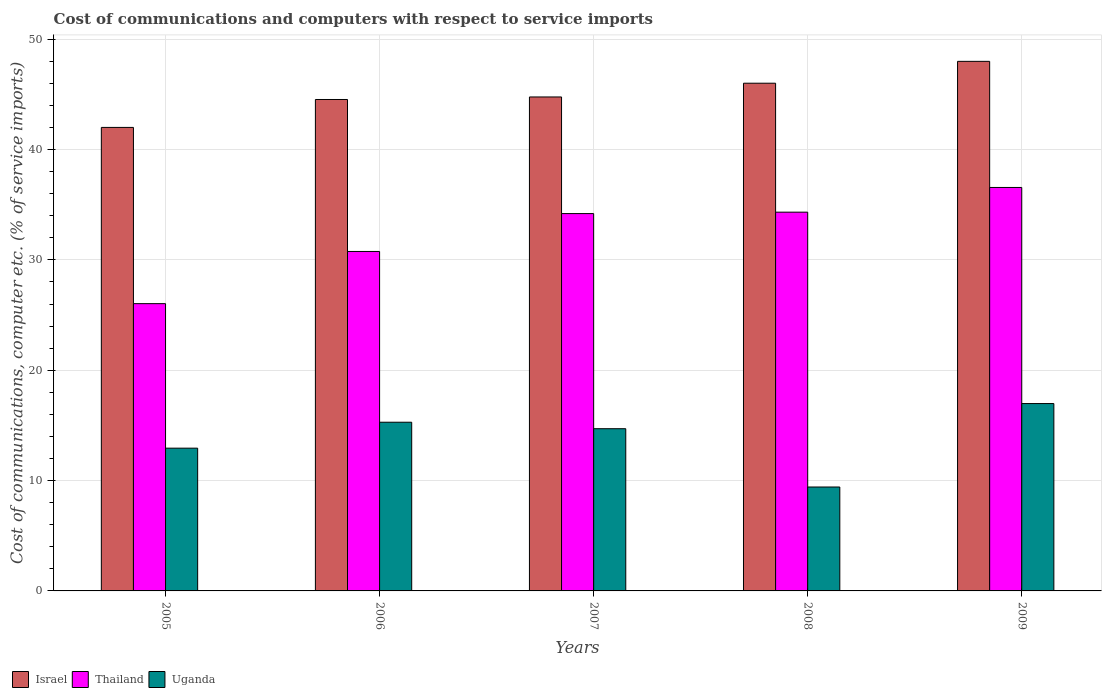How many groups of bars are there?
Your answer should be very brief. 5. Are the number of bars on each tick of the X-axis equal?
Provide a succinct answer. Yes. How many bars are there on the 3rd tick from the left?
Your answer should be very brief. 3. How many bars are there on the 2nd tick from the right?
Your answer should be compact. 3. What is the label of the 5th group of bars from the left?
Your response must be concise. 2009. In how many cases, is the number of bars for a given year not equal to the number of legend labels?
Offer a terse response. 0. What is the cost of communications and computers in Thailand in 2006?
Offer a very short reply. 30.77. Across all years, what is the maximum cost of communications and computers in Thailand?
Your answer should be very brief. 36.57. Across all years, what is the minimum cost of communications and computers in Uganda?
Provide a short and direct response. 9.42. In which year was the cost of communications and computers in Israel maximum?
Give a very brief answer. 2009. What is the total cost of communications and computers in Thailand in the graph?
Provide a succinct answer. 161.89. What is the difference between the cost of communications and computers in Thailand in 2007 and that in 2009?
Ensure brevity in your answer.  -2.37. What is the difference between the cost of communications and computers in Uganda in 2009 and the cost of communications and computers in Thailand in 2006?
Provide a short and direct response. -13.78. What is the average cost of communications and computers in Israel per year?
Make the answer very short. 45.06. In the year 2005, what is the difference between the cost of communications and computers in Thailand and cost of communications and computers in Uganda?
Offer a terse response. 13.1. In how many years, is the cost of communications and computers in Uganda greater than 22 %?
Your answer should be very brief. 0. What is the ratio of the cost of communications and computers in Israel in 2005 to that in 2009?
Offer a terse response. 0.88. What is the difference between the highest and the second highest cost of communications and computers in Israel?
Keep it short and to the point. 1.98. What is the difference between the highest and the lowest cost of communications and computers in Thailand?
Make the answer very short. 10.53. In how many years, is the cost of communications and computers in Thailand greater than the average cost of communications and computers in Thailand taken over all years?
Make the answer very short. 3. Is the sum of the cost of communications and computers in Israel in 2005 and 2009 greater than the maximum cost of communications and computers in Uganda across all years?
Keep it short and to the point. Yes. What does the 3rd bar from the left in 2007 represents?
Your answer should be compact. Uganda. What does the 3rd bar from the right in 2006 represents?
Provide a short and direct response. Israel. Is it the case that in every year, the sum of the cost of communications and computers in Israel and cost of communications and computers in Thailand is greater than the cost of communications and computers in Uganda?
Your response must be concise. Yes. How many bars are there?
Offer a very short reply. 15. What is the difference between two consecutive major ticks on the Y-axis?
Your response must be concise. 10. Are the values on the major ticks of Y-axis written in scientific E-notation?
Keep it short and to the point. No. Does the graph contain any zero values?
Keep it short and to the point. No. Does the graph contain grids?
Offer a very short reply. Yes. How many legend labels are there?
Offer a terse response. 3. What is the title of the graph?
Keep it short and to the point. Cost of communications and computers with respect to service imports. Does "Ghana" appear as one of the legend labels in the graph?
Keep it short and to the point. No. What is the label or title of the Y-axis?
Ensure brevity in your answer.  Cost of communications, computer etc. (% of service imports). What is the Cost of communications, computer etc. (% of service imports) of Israel in 2005?
Provide a succinct answer. 42.01. What is the Cost of communications, computer etc. (% of service imports) of Thailand in 2005?
Your answer should be very brief. 26.04. What is the Cost of communications, computer etc. (% of service imports) of Uganda in 2005?
Make the answer very short. 12.94. What is the Cost of communications, computer etc. (% of service imports) in Israel in 2006?
Your response must be concise. 44.54. What is the Cost of communications, computer etc. (% of service imports) of Thailand in 2006?
Ensure brevity in your answer.  30.77. What is the Cost of communications, computer etc. (% of service imports) of Uganda in 2006?
Provide a succinct answer. 15.29. What is the Cost of communications, computer etc. (% of service imports) in Israel in 2007?
Offer a terse response. 44.77. What is the Cost of communications, computer etc. (% of service imports) of Thailand in 2007?
Your answer should be compact. 34.2. What is the Cost of communications, computer etc. (% of service imports) of Uganda in 2007?
Your answer should be very brief. 14.7. What is the Cost of communications, computer etc. (% of service imports) of Israel in 2008?
Offer a terse response. 46.01. What is the Cost of communications, computer etc. (% of service imports) in Thailand in 2008?
Your response must be concise. 34.33. What is the Cost of communications, computer etc. (% of service imports) of Uganda in 2008?
Keep it short and to the point. 9.42. What is the Cost of communications, computer etc. (% of service imports) in Israel in 2009?
Provide a succinct answer. 48. What is the Cost of communications, computer etc. (% of service imports) in Thailand in 2009?
Make the answer very short. 36.57. What is the Cost of communications, computer etc. (% of service imports) of Uganda in 2009?
Your response must be concise. 16.98. Across all years, what is the maximum Cost of communications, computer etc. (% of service imports) in Israel?
Ensure brevity in your answer.  48. Across all years, what is the maximum Cost of communications, computer etc. (% of service imports) in Thailand?
Provide a succinct answer. 36.57. Across all years, what is the maximum Cost of communications, computer etc. (% of service imports) in Uganda?
Your answer should be very brief. 16.98. Across all years, what is the minimum Cost of communications, computer etc. (% of service imports) in Israel?
Make the answer very short. 42.01. Across all years, what is the minimum Cost of communications, computer etc. (% of service imports) in Thailand?
Your answer should be very brief. 26.04. Across all years, what is the minimum Cost of communications, computer etc. (% of service imports) of Uganda?
Offer a very short reply. 9.42. What is the total Cost of communications, computer etc. (% of service imports) in Israel in the graph?
Your answer should be very brief. 225.32. What is the total Cost of communications, computer etc. (% of service imports) in Thailand in the graph?
Make the answer very short. 161.89. What is the total Cost of communications, computer etc. (% of service imports) of Uganda in the graph?
Offer a terse response. 69.33. What is the difference between the Cost of communications, computer etc. (% of service imports) in Israel in 2005 and that in 2006?
Keep it short and to the point. -2.53. What is the difference between the Cost of communications, computer etc. (% of service imports) of Thailand in 2005 and that in 2006?
Your response must be concise. -4.73. What is the difference between the Cost of communications, computer etc. (% of service imports) of Uganda in 2005 and that in 2006?
Ensure brevity in your answer.  -2.35. What is the difference between the Cost of communications, computer etc. (% of service imports) of Israel in 2005 and that in 2007?
Provide a short and direct response. -2.76. What is the difference between the Cost of communications, computer etc. (% of service imports) in Thailand in 2005 and that in 2007?
Keep it short and to the point. -8.16. What is the difference between the Cost of communications, computer etc. (% of service imports) in Uganda in 2005 and that in 2007?
Make the answer very short. -1.76. What is the difference between the Cost of communications, computer etc. (% of service imports) in Israel in 2005 and that in 2008?
Offer a terse response. -4.01. What is the difference between the Cost of communications, computer etc. (% of service imports) of Thailand in 2005 and that in 2008?
Your answer should be very brief. -8.29. What is the difference between the Cost of communications, computer etc. (% of service imports) of Uganda in 2005 and that in 2008?
Provide a short and direct response. 3.52. What is the difference between the Cost of communications, computer etc. (% of service imports) in Israel in 2005 and that in 2009?
Ensure brevity in your answer.  -5.99. What is the difference between the Cost of communications, computer etc. (% of service imports) of Thailand in 2005 and that in 2009?
Offer a very short reply. -10.53. What is the difference between the Cost of communications, computer etc. (% of service imports) of Uganda in 2005 and that in 2009?
Provide a succinct answer. -4.04. What is the difference between the Cost of communications, computer etc. (% of service imports) of Israel in 2006 and that in 2007?
Make the answer very short. -0.23. What is the difference between the Cost of communications, computer etc. (% of service imports) of Thailand in 2006 and that in 2007?
Your answer should be very brief. -3.43. What is the difference between the Cost of communications, computer etc. (% of service imports) in Uganda in 2006 and that in 2007?
Your answer should be very brief. 0.59. What is the difference between the Cost of communications, computer etc. (% of service imports) of Israel in 2006 and that in 2008?
Provide a short and direct response. -1.48. What is the difference between the Cost of communications, computer etc. (% of service imports) in Thailand in 2006 and that in 2008?
Provide a succinct answer. -3.56. What is the difference between the Cost of communications, computer etc. (% of service imports) of Uganda in 2006 and that in 2008?
Ensure brevity in your answer.  5.87. What is the difference between the Cost of communications, computer etc. (% of service imports) of Israel in 2006 and that in 2009?
Your answer should be compact. -3.46. What is the difference between the Cost of communications, computer etc. (% of service imports) in Thailand in 2006 and that in 2009?
Offer a terse response. -5.8. What is the difference between the Cost of communications, computer etc. (% of service imports) in Uganda in 2006 and that in 2009?
Your answer should be very brief. -1.69. What is the difference between the Cost of communications, computer etc. (% of service imports) in Israel in 2007 and that in 2008?
Your response must be concise. -1.25. What is the difference between the Cost of communications, computer etc. (% of service imports) of Thailand in 2007 and that in 2008?
Provide a short and direct response. -0.13. What is the difference between the Cost of communications, computer etc. (% of service imports) of Uganda in 2007 and that in 2008?
Provide a short and direct response. 5.28. What is the difference between the Cost of communications, computer etc. (% of service imports) in Israel in 2007 and that in 2009?
Make the answer very short. -3.23. What is the difference between the Cost of communications, computer etc. (% of service imports) in Thailand in 2007 and that in 2009?
Give a very brief answer. -2.37. What is the difference between the Cost of communications, computer etc. (% of service imports) of Uganda in 2007 and that in 2009?
Keep it short and to the point. -2.28. What is the difference between the Cost of communications, computer etc. (% of service imports) in Israel in 2008 and that in 2009?
Your answer should be compact. -1.98. What is the difference between the Cost of communications, computer etc. (% of service imports) in Thailand in 2008 and that in 2009?
Offer a very short reply. -2.24. What is the difference between the Cost of communications, computer etc. (% of service imports) in Uganda in 2008 and that in 2009?
Ensure brevity in your answer.  -7.56. What is the difference between the Cost of communications, computer etc. (% of service imports) of Israel in 2005 and the Cost of communications, computer etc. (% of service imports) of Thailand in 2006?
Offer a terse response. 11.24. What is the difference between the Cost of communications, computer etc. (% of service imports) of Israel in 2005 and the Cost of communications, computer etc. (% of service imports) of Uganda in 2006?
Your answer should be very brief. 26.72. What is the difference between the Cost of communications, computer etc. (% of service imports) of Thailand in 2005 and the Cost of communications, computer etc. (% of service imports) of Uganda in 2006?
Offer a terse response. 10.75. What is the difference between the Cost of communications, computer etc. (% of service imports) of Israel in 2005 and the Cost of communications, computer etc. (% of service imports) of Thailand in 2007?
Your answer should be very brief. 7.81. What is the difference between the Cost of communications, computer etc. (% of service imports) of Israel in 2005 and the Cost of communications, computer etc. (% of service imports) of Uganda in 2007?
Give a very brief answer. 27.31. What is the difference between the Cost of communications, computer etc. (% of service imports) of Thailand in 2005 and the Cost of communications, computer etc. (% of service imports) of Uganda in 2007?
Your answer should be compact. 11.33. What is the difference between the Cost of communications, computer etc. (% of service imports) in Israel in 2005 and the Cost of communications, computer etc. (% of service imports) in Thailand in 2008?
Provide a short and direct response. 7.68. What is the difference between the Cost of communications, computer etc. (% of service imports) in Israel in 2005 and the Cost of communications, computer etc. (% of service imports) in Uganda in 2008?
Ensure brevity in your answer.  32.59. What is the difference between the Cost of communications, computer etc. (% of service imports) in Thailand in 2005 and the Cost of communications, computer etc. (% of service imports) in Uganda in 2008?
Ensure brevity in your answer.  16.62. What is the difference between the Cost of communications, computer etc. (% of service imports) of Israel in 2005 and the Cost of communications, computer etc. (% of service imports) of Thailand in 2009?
Provide a short and direct response. 5.44. What is the difference between the Cost of communications, computer etc. (% of service imports) in Israel in 2005 and the Cost of communications, computer etc. (% of service imports) in Uganda in 2009?
Give a very brief answer. 25.03. What is the difference between the Cost of communications, computer etc. (% of service imports) in Thailand in 2005 and the Cost of communications, computer etc. (% of service imports) in Uganda in 2009?
Your answer should be compact. 9.06. What is the difference between the Cost of communications, computer etc. (% of service imports) in Israel in 2006 and the Cost of communications, computer etc. (% of service imports) in Thailand in 2007?
Your response must be concise. 10.34. What is the difference between the Cost of communications, computer etc. (% of service imports) in Israel in 2006 and the Cost of communications, computer etc. (% of service imports) in Uganda in 2007?
Your answer should be compact. 29.84. What is the difference between the Cost of communications, computer etc. (% of service imports) in Thailand in 2006 and the Cost of communications, computer etc. (% of service imports) in Uganda in 2007?
Provide a short and direct response. 16.06. What is the difference between the Cost of communications, computer etc. (% of service imports) in Israel in 2006 and the Cost of communications, computer etc. (% of service imports) in Thailand in 2008?
Your response must be concise. 10.21. What is the difference between the Cost of communications, computer etc. (% of service imports) in Israel in 2006 and the Cost of communications, computer etc. (% of service imports) in Uganda in 2008?
Offer a very short reply. 35.12. What is the difference between the Cost of communications, computer etc. (% of service imports) of Thailand in 2006 and the Cost of communications, computer etc. (% of service imports) of Uganda in 2008?
Your answer should be very brief. 21.35. What is the difference between the Cost of communications, computer etc. (% of service imports) in Israel in 2006 and the Cost of communications, computer etc. (% of service imports) in Thailand in 2009?
Keep it short and to the point. 7.97. What is the difference between the Cost of communications, computer etc. (% of service imports) of Israel in 2006 and the Cost of communications, computer etc. (% of service imports) of Uganda in 2009?
Provide a succinct answer. 27.56. What is the difference between the Cost of communications, computer etc. (% of service imports) in Thailand in 2006 and the Cost of communications, computer etc. (% of service imports) in Uganda in 2009?
Provide a short and direct response. 13.78. What is the difference between the Cost of communications, computer etc. (% of service imports) in Israel in 2007 and the Cost of communications, computer etc. (% of service imports) in Thailand in 2008?
Your answer should be very brief. 10.44. What is the difference between the Cost of communications, computer etc. (% of service imports) of Israel in 2007 and the Cost of communications, computer etc. (% of service imports) of Uganda in 2008?
Provide a short and direct response. 35.35. What is the difference between the Cost of communications, computer etc. (% of service imports) in Thailand in 2007 and the Cost of communications, computer etc. (% of service imports) in Uganda in 2008?
Provide a short and direct response. 24.78. What is the difference between the Cost of communications, computer etc. (% of service imports) in Israel in 2007 and the Cost of communications, computer etc. (% of service imports) in Thailand in 2009?
Ensure brevity in your answer.  8.2. What is the difference between the Cost of communications, computer etc. (% of service imports) in Israel in 2007 and the Cost of communications, computer etc. (% of service imports) in Uganda in 2009?
Keep it short and to the point. 27.79. What is the difference between the Cost of communications, computer etc. (% of service imports) in Thailand in 2007 and the Cost of communications, computer etc. (% of service imports) in Uganda in 2009?
Provide a short and direct response. 17.22. What is the difference between the Cost of communications, computer etc. (% of service imports) in Israel in 2008 and the Cost of communications, computer etc. (% of service imports) in Thailand in 2009?
Give a very brief answer. 9.45. What is the difference between the Cost of communications, computer etc. (% of service imports) in Israel in 2008 and the Cost of communications, computer etc. (% of service imports) in Uganda in 2009?
Offer a terse response. 29.03. What is the difference between the Cost of communications, computer etc. (% of service imports) of Thailand in 2008 and the Cost of communications, computer etc. (% of service imports) of Uganda in 2009?
Make the answer very short. 17.35. What is the average Cost of communications, computer etc. (% of service imports) in Israel per year?
Offer a terse response. 45.06. What is the average Cost of communications, computer etc. (% of service imports) in Thailand per year?
Provide a succinct answer. 32.38. What is the average Cost of communications, computer etc. (% of service imports) in Uganda per year?
Make the answer very short. 13.87. In the year 2005, what is the difference between the Cost of communications, computer etc. (% of service imports) in Israel and Cost of communications, computer etc. (% of service imports) in Thailand?
Keep it short and to the point. 15.97. In the year 2005, what is the difference between the Cost of communications, computer etc. (% of service imports) of Israel and Cost of communications, computer etc. (% of service imports) of Uganda?
Keep it short and to the point. 29.07. In the year 2005, what is the difference between the Cost of communications, computer etc. (% of service imports) in Thailand and Cost of communications, computer etc. (% of service imports) in Uganda?
Make the answer very short. 13.1. In the year 2006, what is the difference between the Cost of communications, computer etc. (% of service imports) in Israel and Cost of communications, computer etc. (% of service imports) in Thailand?
Make the answer very short. 13.77. In the year 2006, what is the difference between the Cost of communications, computer etc. (% of service imports) of Israel and Cost of communications, computer etc. (% of service imports) of Uganda?
Ensure brevity in your answer.  29.25. In the year 2006, what is the difference between the Cost of communications, computer etc. (% of service imports) of Thailand and Cost of communications, computer etc. (% of service imports) of Uganda?
Your answer should be compact. 15.48. In the year 2007, what is the difference between the Cost of communications, computer etc. (% of service imports) of Israel and Cost of communications, computer etc. (% of service imports) of Thailand?
Give a very brief answer. 10.57. In the year 2007, what is the difference between the Cost of communications, computer etc. (% of service imports) in Israel and Cost of communications, computer etc. (% of service imports) in Uganda?
Your answer should be compact. 30.07. In the year 2007, what is the difference between the Cost of communications, computer etc. (% of service imports) in Thailand and Cost of communications, computer etc. (% of service imports) in Uganda?
Give a very brief answer. 19.5. In the year 2008, what is the difference between the Cost of communications, computer etc. (% of service imports) of Israel and Cost of communications, computer etc. (% of service imports) of Thailand?
Ensure brevity in your answer.  11.69. In the year 2008, what is the difference between the Cost of communications, computer etc. (% of service imports) of Israel and Cost of communications, computer etc. (% of service imports) of Uganda?
Make the answer very short. 36.6. In the year 2008, what is the difference between the Cost of communications, computer etc. (% of service imports) in Thailand and Cost of communications, computer etc. (% of service imports) in Uganda?
Your answer should be compact. 24.91. In the year 2009, what is the difference between the Cost of communications, computer etc. (% of service imports) in Israel and Cost of communications, computer etc. (% of service imports) in Thailand?
Provide a succinct answer. 11.43. In the year 2009, what is the difference between the Cost of communications, computer etc. (% of service imports) of Israel and Cost of communications, computer etc. (% of service imports) of Uganda?
Provide a succinct answer. 31.01. In the year 2009, what is the difference between the Cost of communications, computer etc. (% of service imports) of Thailand and Cost of communications, computer etc. (% of service imports) of Uganda?
Offer a very short reply. 19.58. What is the ratio of the Cost of communications, computer etc. (% of service imports) of Israel in 2005 to that in 2006?
Keep it short and to the point. 0.94. What is the ratio of the Cost of communications, computer etc. (% of service imports) of Thailand in 2005 to that in 2006?
Provide a short and direct response. 0.85. What is the ratio of the Cost of communications, computer etc. (% of service imports) of Uganda in 2005 to that in 2006?
Ensure brevity in your answer.  0.85. What is the ratio of the Cost of communications, computer etc. (% of service imports) in Israel in 2005 to that in 2007?
Give a very brief answer. 0.94. What is the ratio of the Cost of communications, computer etc. (% of service imports) of Thailand in 2005 to that in 2007?
Keep it short and to the point. 0.76. What is the ratio of the Cost of communications, computer etc. (% of service imports) in Uganda in 2005 to that in 2007?
Your answer should be compact. 0.88. What is the ratio of the Cost of communications, computer etc. (% of service imports) in Israel in 2005 to that in 2008?
Offer a very short reply. 0.91. What is the ratio of the Cost of communications, computer etc. (% of service imports) in Thailand in 2005 to that in 2008?
Provide a succinct answer. 0.76. What is the ratio of the Cost of communications, computer etc. (% of service imports) in Uganda in 2005 to that in 2008?
Offer a very short reply. 1.37. What is the ratio of the Cost of communications, computer etc. (% of service imports) in Israel in 2005 to that in 2009?
Offer a very short reply. 0.88. What is the ratio of the Cost of communications, computer etc. (% of service imports) of Thailand in 2005 to that in 2009?
Keep it short and to the point. 0.71. What is the ratio of the Cost of communications, computer etc. (% of service imports) of Uganda in 2005 to that in 2009?
Keep it short and to the point. 0.76. What is the ratio of the Cost of communications, computer etc. (% of service imports) in Israel in 2006 to that in 2007?
Your answer should be very brief. 0.99. What is the ratio of the Cost of communications, computer etc. (% of service imports) of Thailand in 2006 to that in 2007?
Give a very brief answer. 0.9. What is the ratio of the Cost of communications, computer etc. (% of service imports) of Israel in 2006 to that in 2008?
Provide a succinct answer. 0.97. What is the ratio of the Cost of communications, computer etc. (% of service imports) in Thailand in 2006 to that in 2008?
Provide a succinct answer. 0.9. What is the ratio of the Cost of communications, computer etc. (% of service imports) in Uganda in 2006 to that in 2008?
Make the answer very short. 1.62. What is the ratio of the Cost of communications, computer etc. (% of service imports) in Israel in 2006 to that in 2009?
Keep it short and to the point. 0.93. What is the ratio of the Cost of communications, computer etc. (% of service imports) in Thailand in 2006 to that in 2009?
Keep it short and to the point. 0.84. What is the ratio of the Cost of communications, computer etc. (% of service imports) in Uganda in 2006 to that in 2009?
Provide a succinct answer. 0.9. What is the ratio of the Cost of communications, computer etc. (% of service imports) of Israel in 2007 to that in 2008?
Ensure brevity in your answer.  0.97. What is the ratio of the Cost of communications, computer etc. (% of service imports) in Uganda in 2007 to that in 2008?
Ensure brevity in your answer.  1.56. What is the ratio of the Cost of communications, computer etc. (% of service imports) of Israel in 2007 to that in 2009?
Ensure brevity in your answer.  0.93. What is the ratio of the Cost of communications, computer etc. (% of service imports) in Thailand in 2007 to that in 2009?
Provide a short and direct response. 0.94. What is the ratio of the Cost of communications, computer etc. (% of service imports) of Uganda in 2007 to that in 2009?
Give a very brief answer. 0.87. What is the ratio of the Cost of communications, computer etc. (% of service imports) in Israel in 2008 to that in 2009?
Offer a terse response. 0.96. What is the ratio of the Cost of communications, computer etc. (% of service imports) in Thailand in 2008 to that in 2009?
Provide a short and direct response. 0.94. What is the ratio of the Cost of communications, computer etc. (% of service imports) in Uganda in 2008 to that in 2009?
Your answer should be very brief. 0.55. What is the difference between the highest and the second highest Cost of communications, computer etc. (% of service imports) of Israel?
Keep it short and to the point. 1.98. What is the difference between the highest and the second highest Cost of communications, computer etc. (% of service imports) of Thailand?
Provide a short and direct response. 2.24. What is the difference between the highest and the second highest Cost of communications, computer etc. (% of service imports) of Uganda?
Your answer should be very brief. 1.69. What is the difference between the highest and the lowest Cost of communications, computer etc. (% of service imports) in Israel?
Give a very brief answer. 5.99. What is the difference between the highest and the lowest Cost of communications, computer etc. (% of service imports) of Thailand?
Ensure brevity in your answer.  10.53. What is the difference between the highest and the lowest Cost of communications, computer etc. (% of service imports) in Uganda?
Provide a succinct answer. 7.56. 